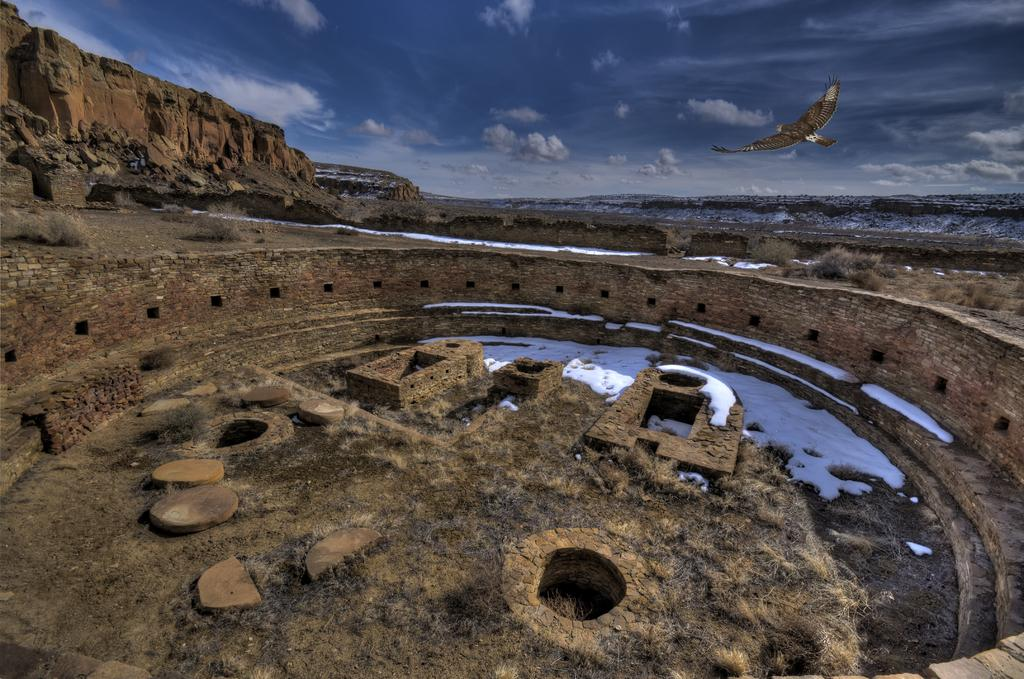What type of weather is depicted in the image? The sky is cloudy in the image, indicating a cloudy weather condition. What natural feature is visible in the image? There is a mountain in the image. What is present on the ground in the image? There is snow and stones visible in the image. What is happening in the sky in the image? A bird is flying in the sky in the image. What type of egg is being transported by the truck in the image? There is no truck present in the image, so there is no egg being transported. What type of stitch is being used to sew the bird in the image? The bird in the image is not a sewn object, so there is no stitch involved. 